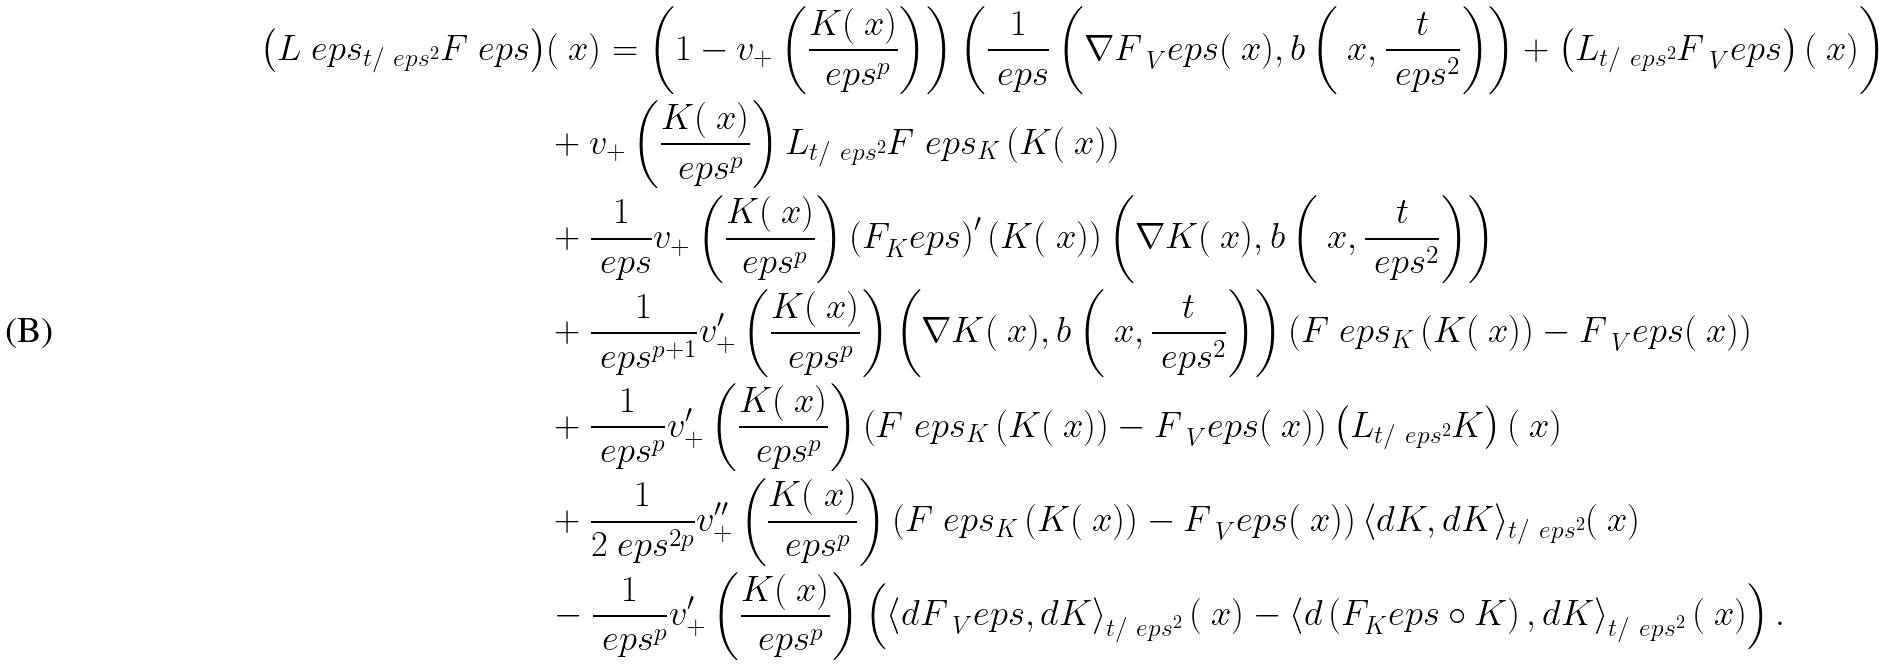Convert formula to latex. <formula><loc_0><loc_0><loc_500><loc_500>\left ( \L L ^ { \ } e p s _ { t / \ e p s ^ { 2 } } F ^ { \ } e p s \right ) & ( \ x ) = \left ( 1 - v _ { + } \left ( \frac { K ( \ x ) } { \ e p s ^ { p } } \right ) \right ) \left ( \frac { 1 } { \ e p s } \left ( \nabla F _ { \ V } ^ { \ } e p s ( \ x ) , b \left ( \ x , \frac { t } { \ e p s ^ { 2 } } \right ) \right ) + \left ( \L L _ { t / \ e p s ^ { 2 } } F _ { \ V } ^ { \ } e p s \right ) ( \ x ) \right ) \\ & + v _ { + } \left ( \frac { K ( \ x ) } { \ e p s ^ { p } } \right ) \L L _ { t / \ e p s ^ { 2 } } F ^ { \ } e p s _ { K } \left ( K ( \ x ) \right ) \\ & + \frac { 1 } { \ e p s } v _ { + } \left ( \frac { K ( \ x ) } { \ e p s ^ { p } } \right ) \left ( F _ { K } ^ { \ } e p s \right ) ^ { \prime } ( K ( \ x ) ) \left ( \nabla K ( \ x ) , b \left ( \ x , \frac { t } { \ e p s ^ { 2 } } \right ) \right ) \\ & + \frac { 1 } { \ e p s ^ { p + 1 } } v ^ { \prime } _ { + } \left ( \frac { K ( \ x ) } { \ e p s ^ { p } } \right ) \left ( \nabla K ( \ x ) , b \left ( \ x , \frac { t } { \ e p s ^ { 2 } } \right ) \right ) \left ( F ^ { \ } e p s _ { K } \left ( K ( \ x ) \right ) - F _ { \ V } ^ { \ } e p s ( \ x ) \right ) \\ & + \frac { 1 } { \ e p s ^ { p } } v ^ { \prime } _ { + } \left ( \frac { K ( \ x ) } { \ e p s ^ { p } } \right ) \left ( F ^ { \ } e p s _ { K } \left ( K ( \ x ) \right ) - F _ { \ V } ^ { \ } e p s ( \ x ) \right ) \left ( \L L _ { t / \ e p s ^ { 2 } } K \right ) ( \ x ) \\ & + \frac { 1 } { 2 \ e p s ^ { 2 p } } v ^ { \prime \prime } _ { + } \left ( \frac { K ( \ x ) } { \ e p s ^ { p } } \right ) \left ( F ^ { \ } e p s _ { K } \left ( K ( \ x ) \right ) - F _ { \ V } ^ { \ } e p s ( \ x ) \right ) \langle d K , d K \rangle _ { t / \ e p s ^ { 2 } } ( \ x ) \\ & - \frac { 1 } { \ e p s ^ { p } } v ^ { \prime } _ { + } \left ( \frac { K ( \ x ) } { \ e p s ^ { p } } \right ) \left ( \left \langle d F _ { \ V } ^ { \ } e p s , d K \right \rangle _ { t / \ e p s ^ { 2 } } \left ( \ x \right ) - \left \langle d \left ( F _ { K } ^ { \ } e p s \circ K \right ) , d K \right \rangle _ { t / \ e p s ^ { 2 } } ( \ x ) \right ) .</formula> 